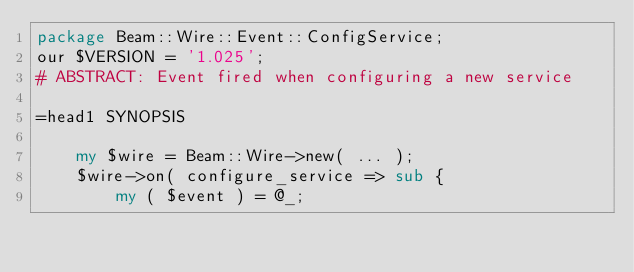<code> <loc_0><loc_0><loc_500><loc_500><_Perl_>package Beam::Wire::Event::ConfigService;
our $VERSION = '1.025';
# ABSTRACT: Event fired when configuring a new service

=head1 SYNOPSIS

    my $wire = Beam::Wire->new( ... );
    $wire->on( configure_service => sub {
        my ( $event ) = @_;</code> 